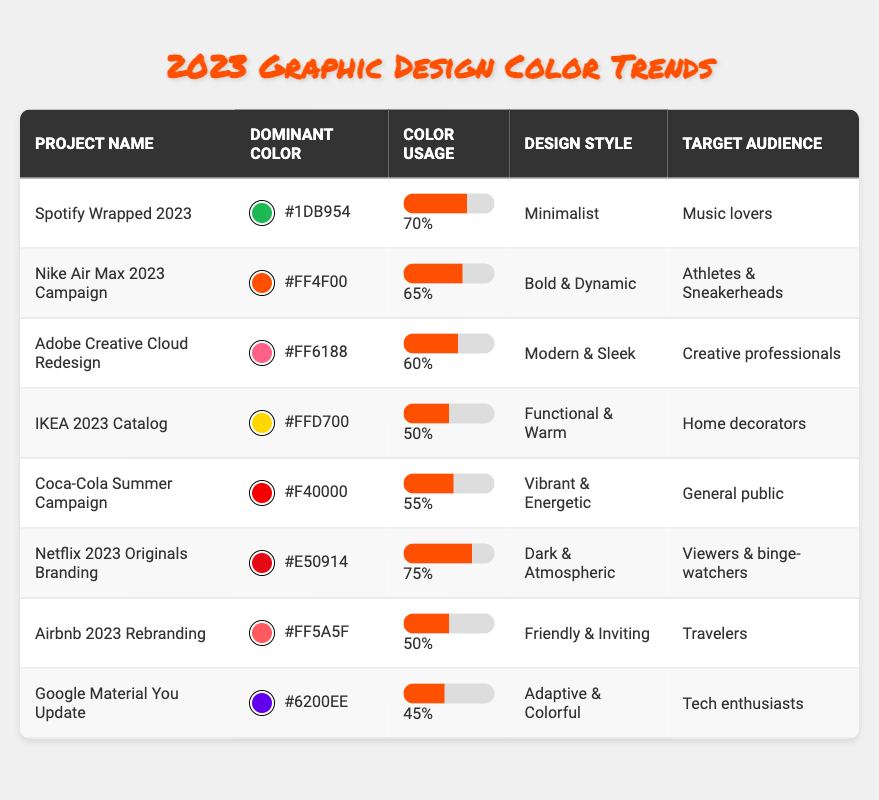What project has the highest color usage percentage? By looking at the table, Netflix 2023 Originals Branding has the highest color usage percentage of 75%.
Answer: Netflix 2023 Originals Branding Which dominant color is used in the Nike Air Max 2023 Campaign? The dominant color for the Nike Air Max 2023 Campaign is #FF4F00.
Answer: #FF4F00 Is the design style for Airbnb 2023 Rebranding "Friendly & Inviting"? Yes, the table indicates that the design style listed for Airbnb 2023 Rebranding is indeed "Friendly & Inviting."
Answer: Yes What is the average color usage percentage among the listed projects? To find the average, sum the percentages (70 + 65 + 60 + 50 + 55 + 75 + 50 + 45) = 570. There are 8 projects, so the average is 570/8 = 71.25.
Answer: 71.25 How many projects have a dominant color usage percentage of 50% or lower? The projects with 50% or lower usage percentages are IKEA 2023 Catalog (50%), Airbnb 2023 Rebranding (50%), and Google Material You Update (45%). Thus, there are 3 projects.
Answer: 3 What is the difference in color usage percentage between Spotify Wrapped 2023 and Coca-Cola Summer Campaign? The color usage percentage for Spotify Wrapped 2023 is 70%, and for Coca-Cola Summer Campaign, it is 55%. The difference is 70 - 55 = 15.
Answer: 15 Which target audience is associated with the project having the second-highest color usage percentage? The project with the second-highest percentage is Nike Air Max 2023 Campaign with 65%. Its target audience is "Athletes & Sneakerheads."
Answer: Athletes & Sneakerheads Is there a project targeting "Creative professionals" that uses a red dominant color? Yes, the Adobe Creative Cloud Redesign targets "Creative professionals" and has the dominant color #FF6188, which is a shade of red.
Answer: Yes 